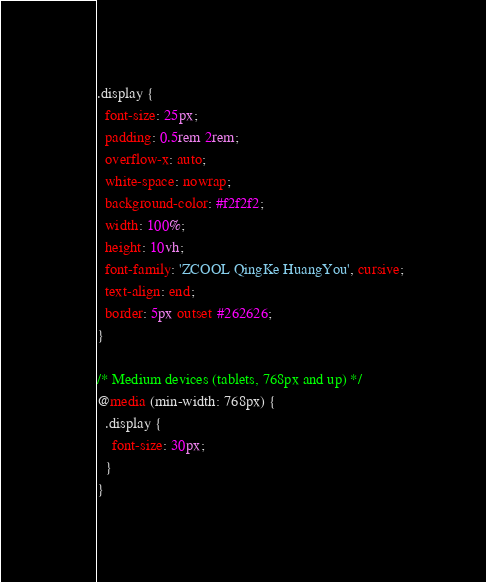<code> <loc_0><loc_0><loc_500><loc_500><_CSS_>.display {
  font-size: 25px;
  padding: 0.5rem 2rem;
  overflow-x: auto;
  white-space: nowrap;
  background-color: #f2f2f2;
  width: 100%;
  height: 10vh;
  font-family: 'ZCOOL QingKe HuangYou', cursive;
  text-align: end;
  border: 5px outset #262626;
}

/* Medium devices (tablets, 768px and up) */
@media (min-width: 768px) {
  .display {
    font-size: 30px;
  }
}
</code> 